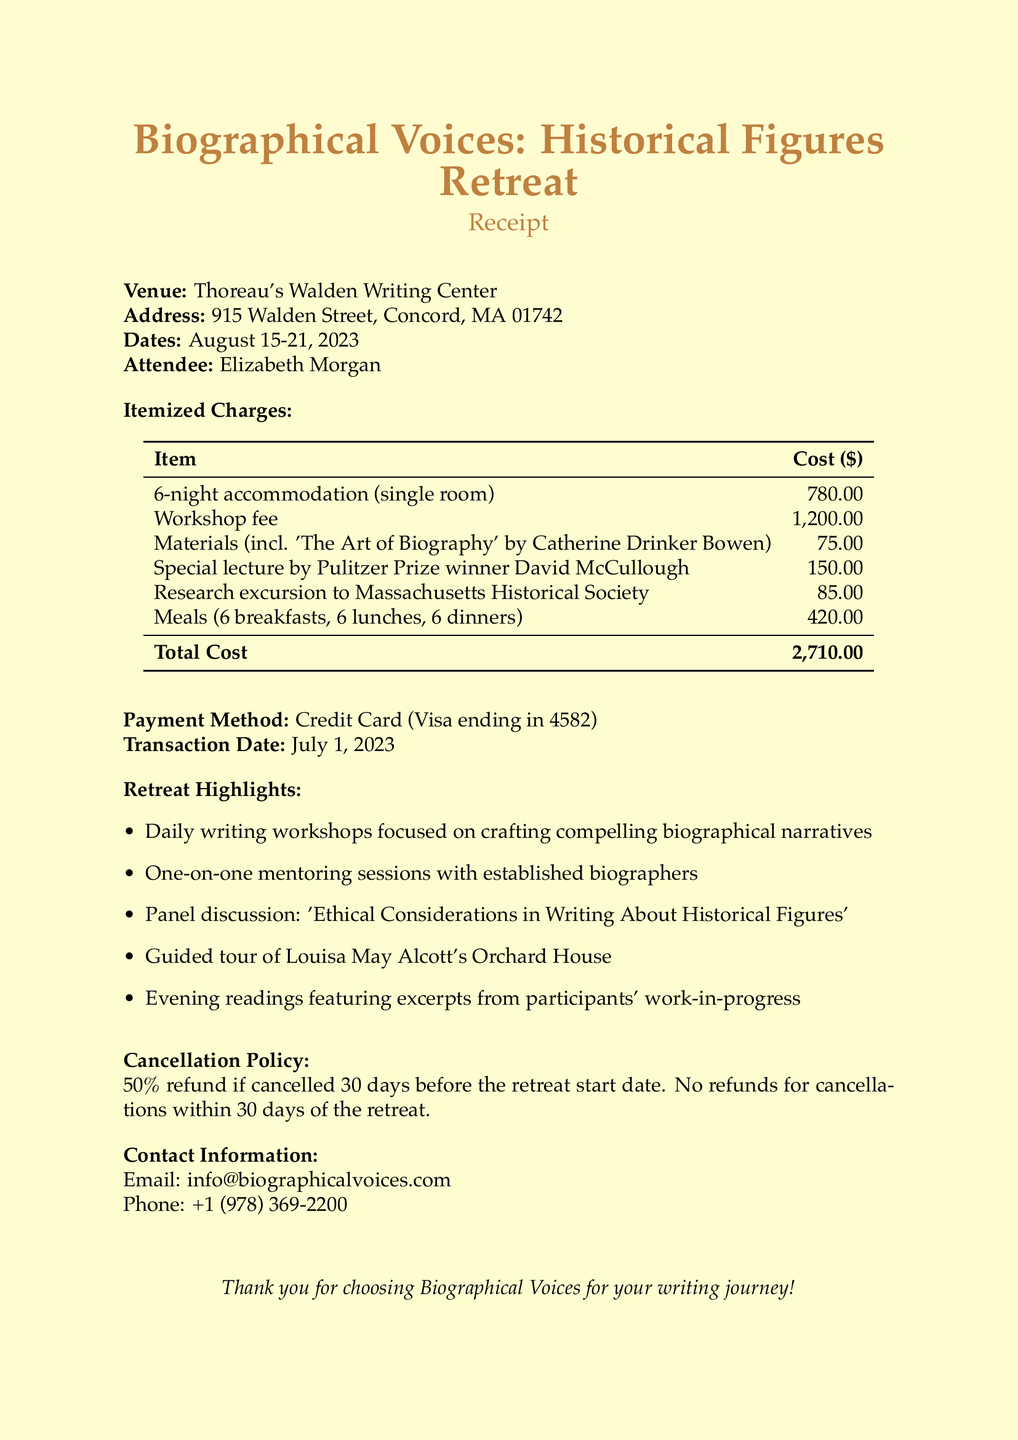what is the name of the retreat? The name of the retreat is mentioned at the top of the document as "Biographical Voices: Historical Figures Retreat."
Answer: Biographical Voices: Historical Figures Retreat who is the attendee? The attendee's name is specified in the document as Elizabeth Morgan.
Answer: Elizabeth Morgan what is the total cost of the retreat? The total cost is clearly listed in the itemized charges section as $2710.
Answer: 2710.00 how many nights of accommodation were booked? The accommodation charge indicates it was for 6 nights.
Answer: 6 nights what is the cancellation policy? The cancellation policy is stated, detailing a 50% refund if cancelled 30 days before the retreat, with no refunds within 30 days.
Answer: 50% refund if cancelled 30 days before the retreat start date. No refunds for cancellations within 30 days who gave the special lecture at the retreat? The document names Pulitzer Prize winner David McCullough as the lecturer for the special lecture session.
Answer: David McCullough how much was charged for meals? The cost for meals is documented as $420, encompassing 6 breakfasts, 6 lunches, and 6 dinners.
Answer: 420.00 what is the venue of the retreat? The venue is specified as "Thoreau's Walden Writing Center" in the document.
Answer: Thoreau's Walden Writing Center when was the transaction date? The transaction date is clearly indicated in the document as July 1, 2023.
Answer: July 1, 2023 